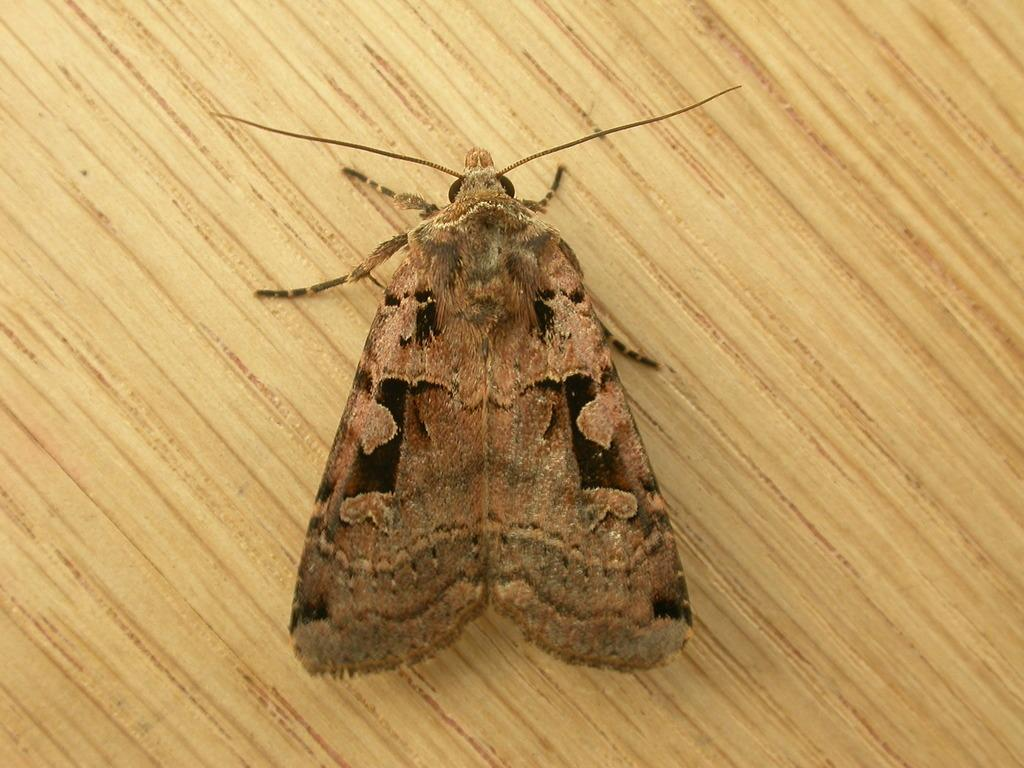What type of creature can be seen in the image? There is an insect in the image. What surface is the insect located on? The insect is on a wooden surface. What hobbies does the insect have in the image? There is no information about the insect's hobbies in the image. What type of calculator is the insect using in the image? There is no calculator present in the image. 